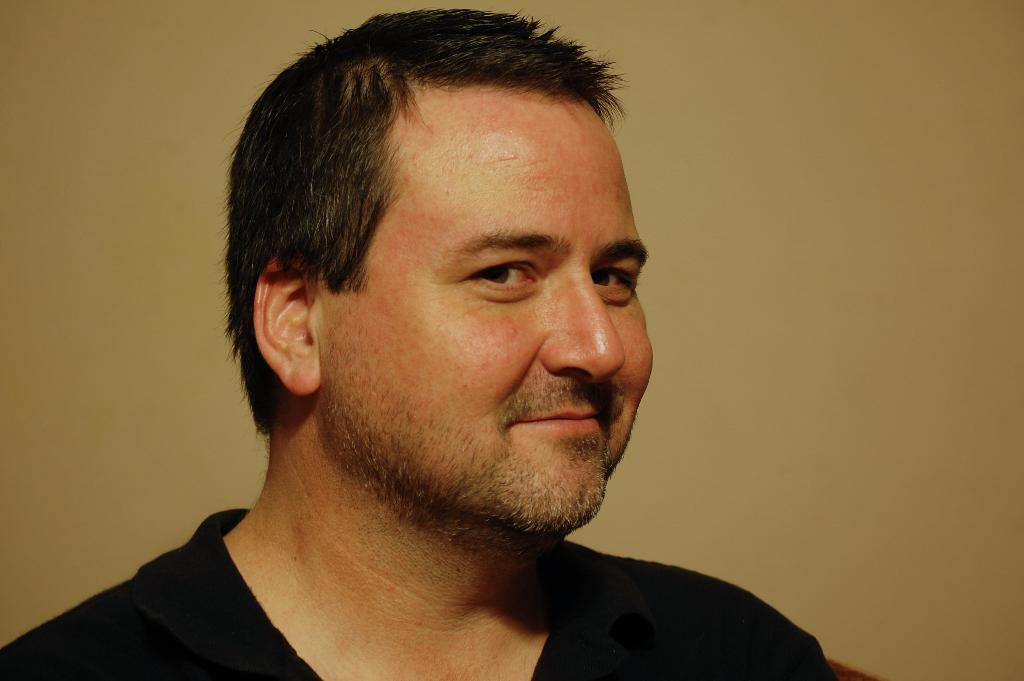Who is present in the image? There is a man in the image. What is the man wearing in the image? The man is wearing a black color T-shirt. What can be seen in the background of the image? The background of the image is light brown in color. What type of beast can be seen in the image? There is no beast present in the image; it features a man wearing a black T-shirt with a light brown background. What drink is the man holding in the image? There is no drink visible in the image. 